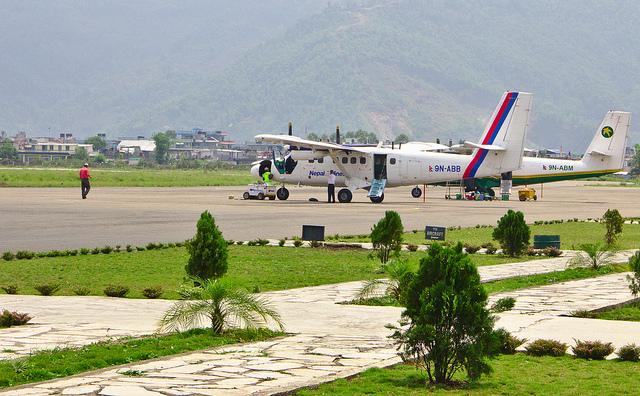Is the plane being loaded or unloaded?
Be succinct. Loaded. Sunny or overcast?
Concise answer only. Overcast. Is the plane taking off?
Give a very brief answer. No. 